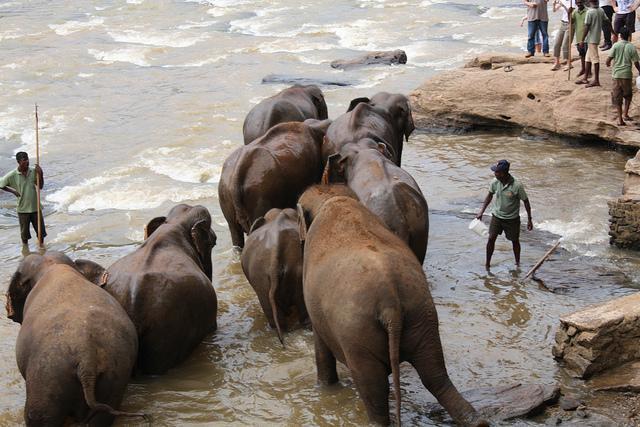How many elephants are there?
Give a very brief answer. 8. How many people are in the photo?
Give a very brief answer. 2. 